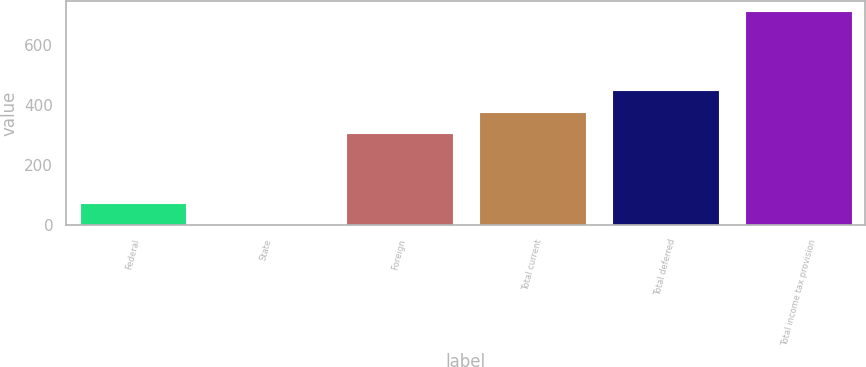<chart> <loc_0><loc_0><loc_500><loc_500><bar_chart><fcel>Federal<fcel>State<fcel>Foreign<fcel>Total current<fcel>Total deferred<fcel>Total income tax provision<nl><fcel>72<fcel>1<fcel>306<fcel>377<fcel>448<fcel>711<nl></chart> 